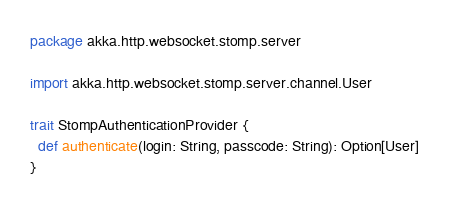Convert code to text. <code><loc_0><loc_0><loc_500><loc_500><_Scala_>package akka.http.websocket.stomp.server

import akka.http.websocket.stomp.server.channel.User

trait StompAuthenticationProvider {
  def authenticate(login: String, passcode: String): Option[User]
}</code> 